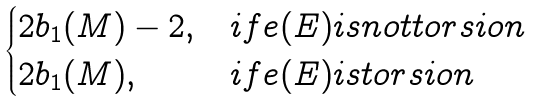<formula> <loc_0><loc_0><loc_500><loc_500>\begin{cases} 2 b _ { 1 } ( M ) - 2 , & i f e ( E ) i s n o t t o r s i o n \\ 2 b _ { 1 } ( M ) , & i f e ( E ) i s t o r s i o n \end{cases}</formula> 